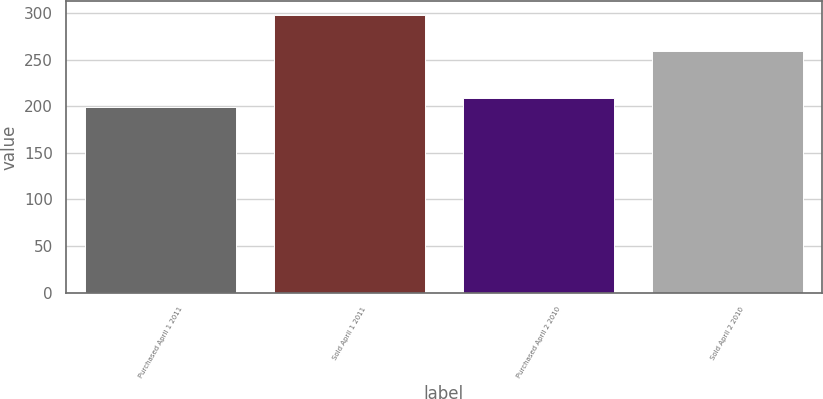<chart> <loc_0><loc_0><loc_500><loc_500><bar_chart><fcel>Purchased April 1 2011<fcel>Sold April 1 2011<fcel>Purchased April 2 2010<fcel>Sold April 2 2010<nl><fcel>199<fcel>298<fcel>208.9<fcel>260<nl></chart> 